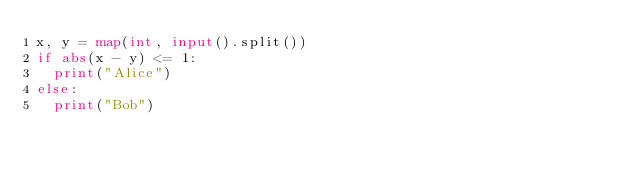Convert code to text. <code><loc_0><loc_0><loc_500><loc_500><_Python_>x, y = map(int, input().split())
if abs(x - y) <= 1:
  print("Alice")
else:
  print("Bob")</code> 